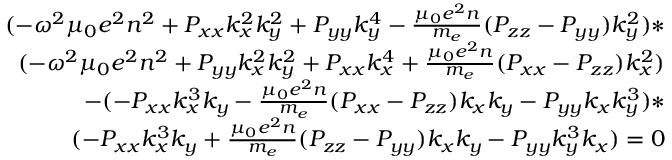<formula> <loc_0><loc_0><loc_500><loc_500>\begin{array} { r } { ( - \omega ^ { 2 } \mu _ { 0 } e ^ { 2 } n ^ { 2 } + P _ { x x } k _ { x } ^ { 2 } k _ { y } ^ { 2 } + P _ { y y } k _ { y } ^ { 4 } - \frac { \mu _ { 0 } e ^ { 2 } n } { m _ { e } } ( P _ { z z } - P _ { y y } ) k _ { y } ^ { 2 } ) * } \\ { ( - \omega ^ { 2 } \mu _ { 0 } e ^ { 2 } n ^ { 2 } + P _ { y y } k _ { x } ^ { 2 } k _ { y } ^ { 2 } + P _ { x x } k _ { x } ^ { 4 } + \frac { \mu _ { 0 } e ^ { 2 } n } { m _ { e } } ( P _ { x x } - P _ { z z } ) k _ { x } ^ { 2 } ) } \\ { - ( - P _ { x x } k _ { x } ^ { 3 } k _ { y } - \frac { \mu _ { 0 } e ^ { 2 } n } { m _ { e } } ( P _ { x x } - P _ { z z } ) k _ { x } k _ { y } - P _ { y y } k _ { x } k _ { y } ^ { 3 } ) * } \\ { ( - P _ { x x } k _ { x } ^ { 3 } k _ { y } + \frac { \mu _ { 0 } e ^ { 2 } n } { m _ { e } } ( P _ { z z } - P _ { y y } ) k _ { x } k _ { y } - P _ { y y } k _ { y } ^ { 3 } k _ { x } ) = 0 } \end{array}</formula> 